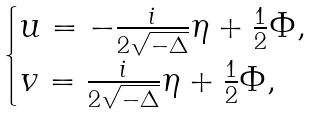Convert formula to latex. <formula><loc_0><loc_0><loc_500><loc_500>\begin{cases} u = - \frac { i } { 2 \sqrt { - \Delta } } \eta + \frac { 1 } { 2 } \Phi , \\ v = \frac { i } { 2 \sqrt { - \Delta } } \eta + \frac { 1 } { 2 } \Phi , \end{cases}</formula> 